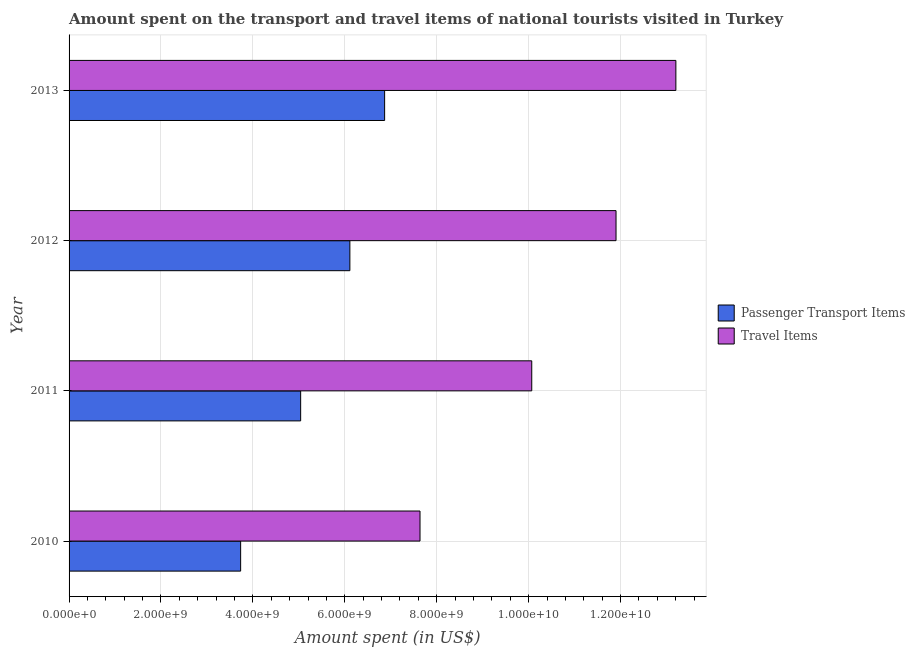How many different coloured bars are there?
Make the answer very short. 2. How many groups of bars are there?
Offer a terse response. 4. How many bars are there on the 3rd tick from the top?
Provide a short and direct response. 2. How many bars are there on the 2nd tick from the bottom?
Provide a short and direct response. 2. What is the label of the 4th group of bars from the top?
Offer a very short reply. 2010. What is the amount spent on passenger transport items in 2011?
Ensure brevity in your answer.  5.04e+09. Across all years, what is the maximum amount spent on passenger transport items?
Provide a short and direct response. 6.87e+09. Across all years, what is the minimum amount spent in travel items?
Your answer should be compact. 7.64e+09. In which year was the amount spent on passenger transport items minimum?
Offer a very short reply. 2010. What is the total amount spent on passenger transport items in the graph?
Your answer should be compact. 2.17e+1. What is the difference between the amount spent on passenger transport items in 2011 and that in 2012?
Your response must be concise. -1.07e+09. What is the difference between the amount spent on passenger transport items in 2010 and the amount spent in travel items in 2013?
Keep it short and to the point. -9.47e+09. What is the average amount spent on passenger transport items per year?
Give a very brief answer. 5.44e+09. In the year 2010, what is the difference between the amount spent in travel items and amount spent on passenger transport items?
Your answer should be compact. 3.90e+09. What is the ratio of the amount spent in travel items in 2011 to that in 2012?
Provide a succinct answer. 0.85. Is the difference between the amount spent in travel items in 2011 and 2013 greater than the difference between the amount spent on passenger transport items in 2011 and 2013?
Offer a terse response. No. What is the difference between the highest and the second highest amount spent in travel items?
Your answer should be compact. 1.30e+09. What is the difference between the highest and the lowest amount spent in travel items?
Make the answer very short. 5.57e+09. Is the sum of the amount spent on passenger transport items in 2012 and 2013 greater than the maximum amount spent in travel items across all years?
Offer a very short reply. No. What does the 2nd bar from the top in 2012 represents?
Offer a very short reply. Passenger Transport Items. What does the 2nd bar from the bottom in 2010 represents?
Your answer should be very brief. Travel Items. Are all the bars in the graph horizontal?
Your answer should be very brief. Yes. How many years are there in the graph?
Provide a succinct answer. 4. Are the values on the major ticks of X-axis written in scientific E-notation?
Offer a terse response. Yes. Where does the legend appear in the graph?
Your answer should be compact. Center right. How many legend labels are there?
Your answer should be very brief. 2. How are the legend labels stacked?
Make the answer very short. Vertical. What is the title of the graph?
Your response must be concise. Amount spent on the transport and travel items of national tourists visited in Turkey. Does "Males" appear as one of the legend labels in the graph?
Your answer should be very brief. No. What is the label or title of the X-axis?
Provide a succinct answer. Amount spent (in US$). What is the Amount spent (in US$) of Passenger Transport Items in 2010?
Give a very brief answer. 3.73e+09. What is the Amount spent (in US$) in Travel Items in 2010?
Provide a short and direct response. 7.64e+09. What is the Amount spent (in US$) in Passenger Transport Items in 2011?
Your response must be concise. 5.04e+09. What is the Amount spent (in US$) of Travel Items in 2011?
Ensure brevity in your answer.  1.01e+1. What is the Amount spent (in US$) in Passenger Transport Items in 2012?
Ensure brevity in your answer.  6.11e+09. What is the Amount spent (in US$) of Travel Items in 2012?
Your response must be concise. 1.19e+1. What is the Amount spent (in US$) of Passenger Transport Items in 2013?
Provide a short and direct response. 6.87e+09. What is the Amount spent (in US$) of Travel Items in 2013?
Your answer should be compact. 1.32e+1. Across all years, what is the maximum Amount spent (in US$) of Passenger Transport Items?
Keep it short and to the point. 6.87e+09. Across all years, what is the maximum Amount spent (in US$) in Travel Items?
Your answer should be compact. 1.32e+1. Across all years, what is the minimum Amount spent (in US$) of Passenger Transport Items?
Ensure brevity in your answer.  3.73e+09. Across all years, what is the minimum Amount spent (in US$) of Travel Items?
Your answer should be compact. 7.64e+09. What is the total Amount spent (in US$) of Passenger Transport Items in the graph?
Ensure brevity in your answer.  2.17e+1. What is the total Amount spent (in US$) of Travel Items in the graph?
Your answer should be very brief. 4.28e+1. What is the difference between the Amount spent (in US$) of Passenger Transport Items in 2010 and that in 2011?
Provide a short and direct response. -1.31e+09. What is the difference between the Amount spent (in US$) in Travel Items in 2010 and that in 2011?
Ensure brevity in your answer.  -2.43e+09. What is the difference between the Amount spent (in US$) in Passenger Transport Items in 2010 and that in 2012?
Keep it short and to the point. -2.38e+09. What is the difference between the Amount spent (in US$) of Travel Items in 2010 and that in 2012?
Your answer should be compact. -4.26e+09. What is the difference between the Amount spent (in US$) in Passenger Transport Items in 2010 and that in 2013?
Provide a short and direct response. -3.13e+09. What is the difference between the Amount spent (in US$) in Travel Items in 2010 and that in 2013?
Offer a terse response. -5.57e+09. What is the difference between the Amount spent (in US$) of Passenger Transport Items in 2011 and that in 2012?
Provide a succinct answer. -1.07e+09. What is the difference between the Amount spent (in US$) in Travel Items in 2011 and that in 2012?
Give a very brief answer. -1.83e+09. What is the difference between the Amount spent (in US$) of Passenger Transport Items in 2011 and that in 2013?
Your answer should be compact. -1.83e+09. What is the difference between the Amount spent (in US$) in Travel Items in 2011 and that in 2013?
Your response must be concise. -3.14e+09. What is the difference between the Amount spent (in US$) in Passenger Transport Items in 2012 and that in 2013?
Keep it short and to the point. -7.56e+08. What is the difference between the Amount spent (in US$) in Travel Items in 2012 and that in 2013?
Ensure brevity in your answer.  -1.30e+09. What is the difference between the Amount spent (in US$) in Passenger Transport Items in 2010 and the Amount spent (in US$) in Travel Items in 2011?
Your answer should be very brief. -6.33e+09. What is the difference between the Amount spent (in US$) of Passenger Transport Items in 2010 and the Amount spent (in US$) of Travel Items in 2012?
Ensure brevity in your answer.  -8.17e+09. What is the difference between the Amount spent (in US$) of Passenger Transport Items in 2010 and the Amount spent (in US$) of Travel Items in 2013?
Make the answer very short. -9.47e+09. What is the difference between the Amount spent (in US$) of Passenger Transport Items in 2011 and the Amount spent (in US$) of Travel Items in 2012?
Ensure brevity in your answer.  -6.86e+09. What is the difference between the Amount spent (in US$) of Passenger Transport Items in 2011 and the Amount spent (in US$) of Travel Items in 2013?
Make the answer very short. -8.16e+09. What is the difference between the Amount spent (in US$) in Passenger Transport Items in 2012 and the Amount spent (in US$) in Travel Items in 2013?
Offer a very short reply. -7.09e+09. What is the average Amount spent (in US$) of Passenger Transport Items per year?
Provide a short and direct response. 5.44e+09. What is the average Amount spent (in US$) of Travel Items per year?
Your answer should be compact. 1.07e+1. In the year 2010, what is the difference between the Amount spent (in US$) of Passenger Transport Items and Amount spent (in US$) of Travel Items?
Give a very brief answer. -3.90e+09. In the year 2011, what is the difference between the Amount spent (in US$) of Passenger Transport Items and Amount spent (in US$) of Travel Items?
Your response must be concise. -5.03e+09. In the year 2012, what is the difference between the Amount spent (in US$) of Passenger Transport Items and Amount spent (in US$) of Travel Items?
Provide a succinct answer. -5.79e+09. In the year 2013, what is the difference between the Amount spent (in US$) of Passenger Transport Items and Amount spent (in US$) of Travel Items?
Provide a succinct answer. -6.34e+09. What is the ratio of the Amount spent (in US$) of Passenger Transport Items in 2010 to that in 2011?
Ensure brevity in your answer.  0.74. What is the ratio of the Amount spent (in US$) in Travel Items in 2010 to that in 2011?
Provide a short and direct response. 0.76. What is the ratio of the Amount spent (in US$) in Passenger Transport Items in 2010 to that in 2012?
Give a very brief answer. 0.61. What is the ratio of the Amount spent (in US$) of Travel Items in 2010 to that in 2012?
Provide a short and direct response. 0.64. What is the ratio of the Amount spent (in US$) of Passenger Transport Items in 2010 to that in 2013?
Offer a very short reply. 0.54. What is the ratio of the Amount spent (in US$) in Travel Items in 2010 to that in 2013?
Give a very brief answer. 0.58. What is the ratio of the Amount spent (in US$) in Passenger Transport Items in 2011 to that in 2012?
Offer a terse response. 0.82. What is the ratio of the Amount spent (in US$) in Travel Items in 2011 to that in 2012?
Your response must be concise. 0.85. What is the ratio of the Amount spent (in US$) of Passenger Transport Items in 2011 to that in 2013?
Your answer should be very brief. 0.73. What is the ratio of the Amount spent (in US$) in Travel Items in 2011 to that in 2013?
Provide a succinct answer. 0.76. What is the ratio of the Amount spent (in US$) in Passenger Transport Items in 2012 to that in 2013?
Give a very brief answer. 0.89. What is the ratio of the Amount spent (in US$) of Travel Items in 2012 to that in 2013?
Your response must be concise. 0.9. What is the difference between the highest and the second highest Amount spent (in US$) in Passenger Transport Items?
Offer a very short reply. 7.56e+08. What is the difference between the highest and the second highest Amount spent (in US$) of Travel Items?
Offer a terse response. 1.30e+09. What is the difference between the highest and the lowest Amount spent (in US$) of Passenger Transport Items?
Your response must be concise. 3.13e+09. What is the difference between the highest and the lowest Amount spent (in US$) of Travel Items?
Offer a very short reply. 5.57e+09. 